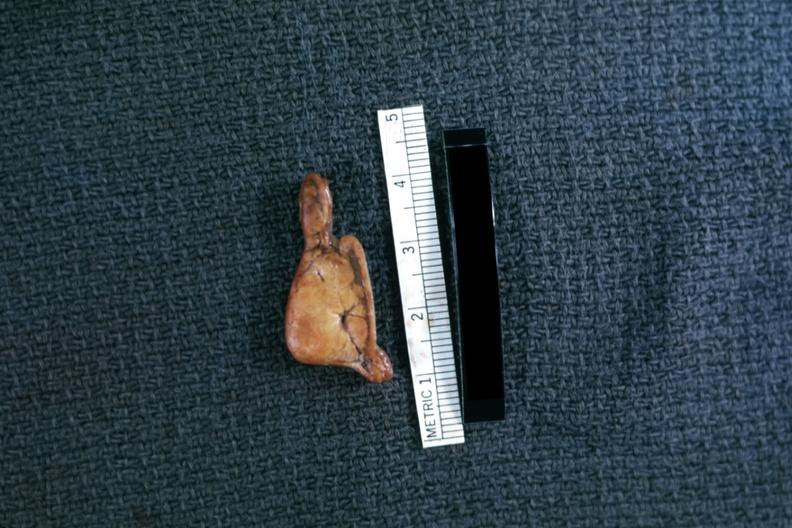what does this image show?
Answer the question using a single word or phrase. Fixed tissue but very good example in cross section 